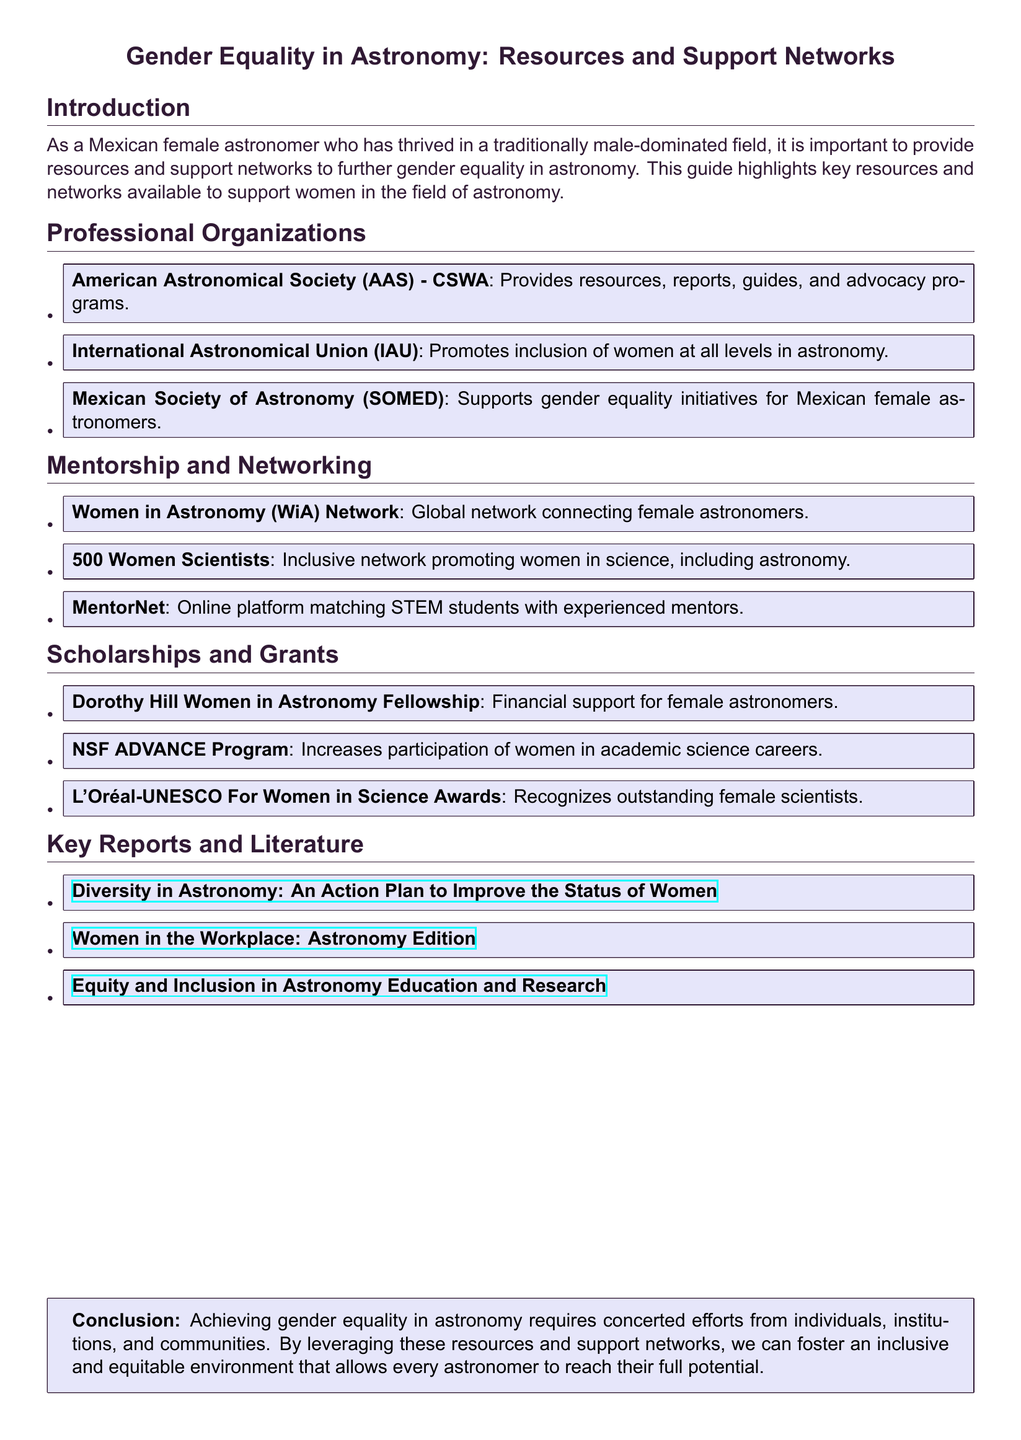What is the main focus of the user guide? The user guide focuses on providing resources and support networks to further gender equality in astronomy.
Answer: Gender equality in astronomy Which organization provides advocacy programs for women in astronomy? The American Astronomical Society (AAS) - CSWA provides advocacy programs for women in astronomy.
Answer: American Astronomical Society (AAS) - CSWA What is the name of the fellowship that supports female astronomers financially? The Dorothy Hill Women in Astronomy Fellowship offers financial support to female astronomers.
Answer: Dorothy Hill Women in Astronomy Fellowship Which program aims to increase participation of women in academic science careers? The NSF ADVANCE Program aims to increase participation of women in academic science careers.
Answer: NSF ADVANCE Program How many professional organizations are listed in the document? There are three professional organizations mentioned in the document.
Answer: Three What is the purpose of the "500 Women Scientists" network? The "500 Women Scientists" network promotes women in science, including astronomy.
Answer: Promoting women in science Which report focuses on improving the status of women in astronomy? The report titled "Diversity in Astronomy: An Action Plan to Improve the Status of Women" focuses on improving the status of women in astronomy.
Answer: Diversity in Astronomy: An Action Plan to Improve the Status of Women What type of support does MentorNet provide? MentorNet provides an online platform matching STEM students with experienced mentors.
Answer: Matching STEM students with mentors How many scholarships and grants are mentioned? The document mentions three scholarships and grants available for female astronomers.
Answer: Three 